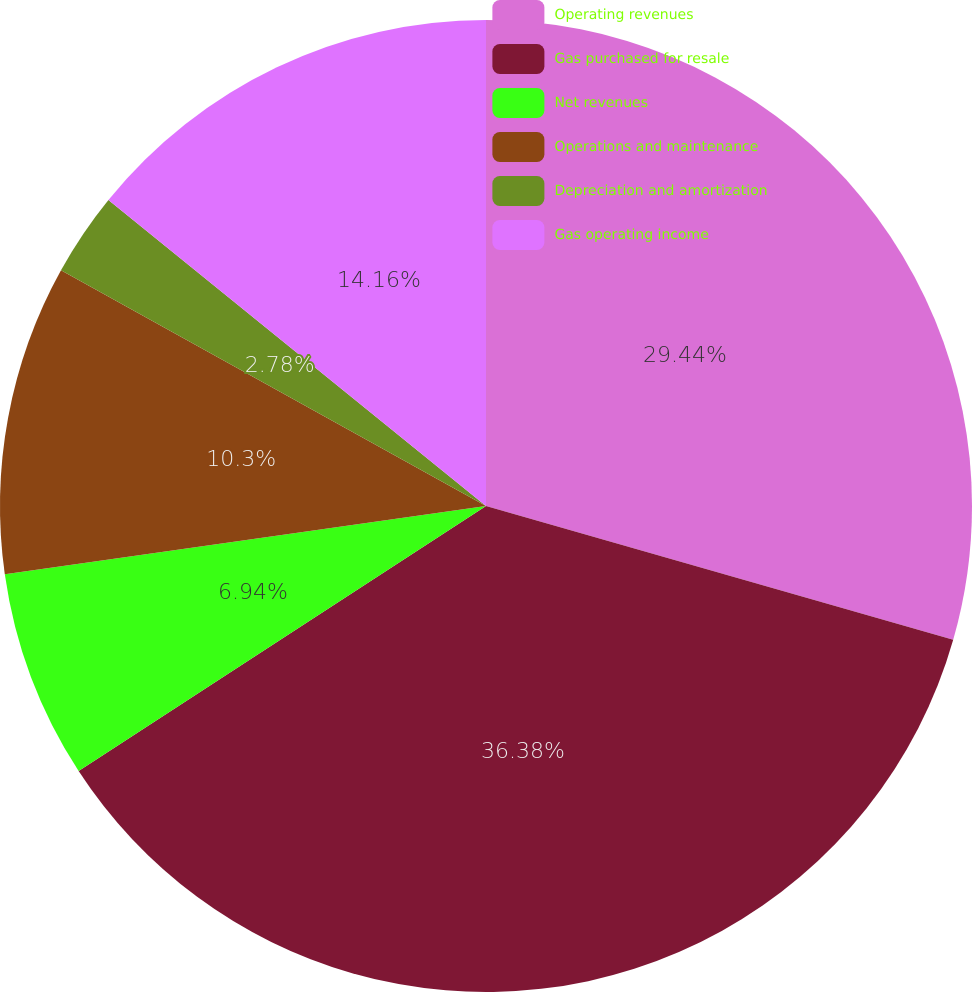Convert chart. <chart><loc_0><loc_0><loc_500><loc_500><pie_chart><fcel>Operating revenues<fcel>Gas purchased for resale<fcel>Net revenues<fcel>Operations and maintenance<fcel>Depreciation and amortization<fcel>Gas operating income<nl><fcel>29.44%<fcel>36.38%<fcel>6.94%<fcel>10.3%<fcel>2.78%<fcel>14.16%<nl></chart> 